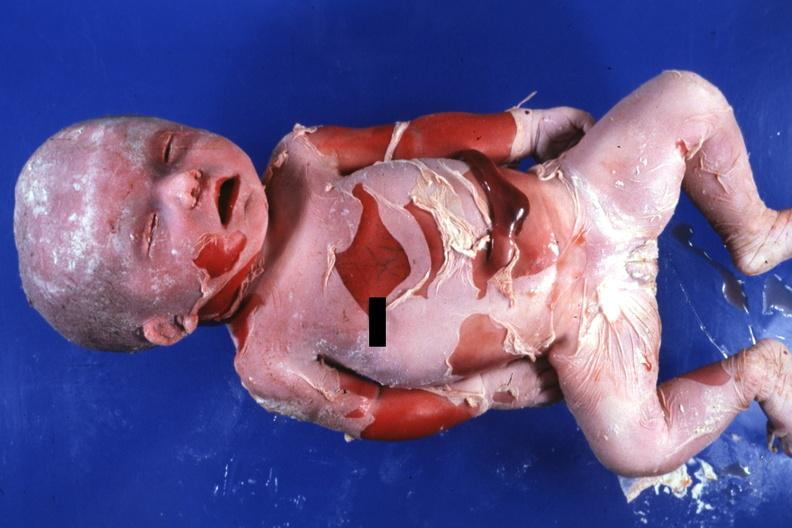s macerated stillborn present?
Answer the question using a single word or phrase. Yes 